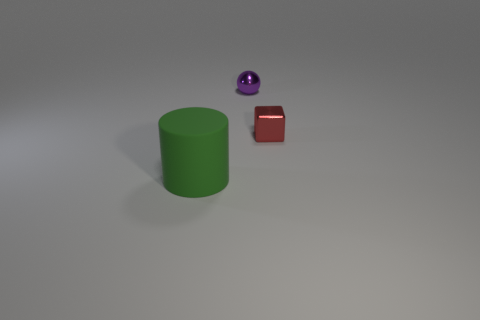Add 2 green matte cubes. How many objects exist? 5 Add 1 purple metallic objects. How many purple metallic objects are left? 2 Add 1 big rubber cylinders. How many big rubber cylinders exist? 2 Subtract 0 yellow cylinders. How many objects are left? 3 Subtract all spheres. How many objects are left? 2 Subtract all big green matte objects. Subtract all big matte things. How many objects are left? 1 